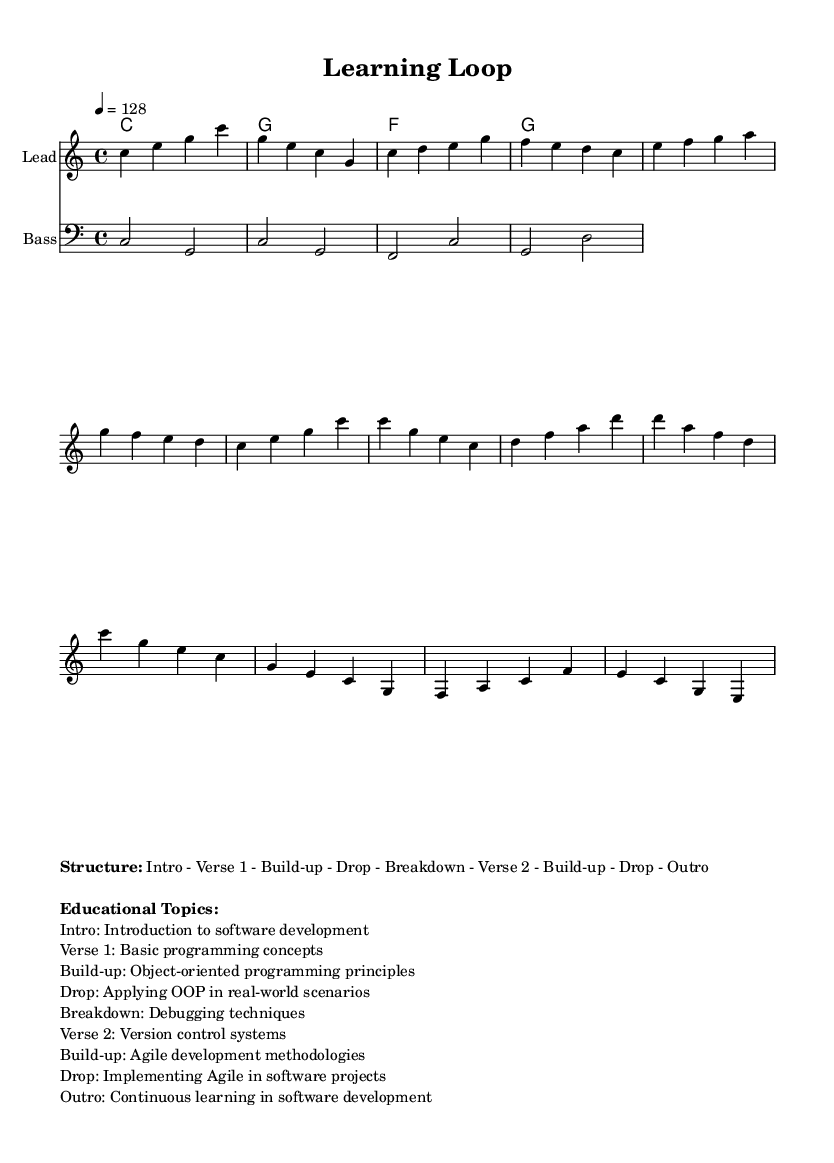What is the key signature of this music? The key signature is C major, which has no sharps or flats.
Answer: C major What is the time signature of the piece? The time signature is 4/4, indicating four beats per measure.
Answer: 4/4 What is the tempo marking given for this music? The tempo marking indicates that the quarter note should be played at 128 beats per minute.
Answer: 128 How many sections are structured in this piece? The structure includes seven distinct sections as outlined in the markup.
Answer: Seven Which educational topic is introduced in the Intro section? The educational topic focused upon in the Intro section is the introduction to software development, highlighting fundamental concepts.
Answer: Introduction to software development What musical elements are used in the Build-up sections? The Build-up sections incorporate elements of object-oriented programming principles followed by agile development methodologies, providing a thematic transition related to software development.
Answer: Object-oriented programming principles, Agile development methodologies Describe the characteristics of the Drop section compared to the Build-up. The Drop section typically has a more energetic feel, showcasing application of learned concepts, while the Build-up prepares listeners for this climax with gradual intensity.
Answer: Energetic feel 